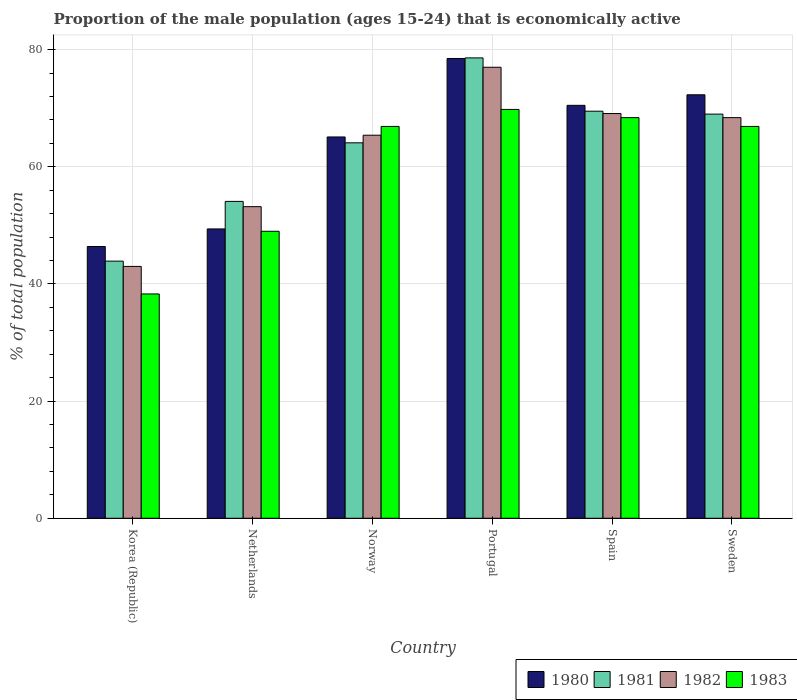How many different coloured bars are there?
Your response must be concise. 4. In how many cases, is the number of bars for a given country not equal to the number of legend labels?
Make the answer very short. 0. What is the proportion of the male population that is economically active in 1983 in Norway?
Your answer should be very brief. 66.9. Across all countries, what is the maximum proportion of the male population that is economically active in 1983?
Your response must be concise. 69.8. What is the total proportion of the male population that is economically active in 1980 in the graph?
Make the answer very short. 382.2. What is the difference between the proportion of the male population that is economically active in 1981 in Netherlands and that in Sweden?
Offer a terse response. -14.9. What is the difference between the proportion of the male population that is economically active in 1981 in Norway and the proportion of the male population that is economically active in 1980 in Portugal?
Offer a terse response. -14.4. What is the average proportion of the male population that is economically active in 1983 per country?
Provide a succinct answer. 59.88. What is the difference between the proportion of the male population that is economically active of/in 1981 and proportion of the male population that is economically active of/in 1983 in Portugal?
Your answer should be compact. 8.8. In how many countries, is the proportion of the male population that is economically active in 1982 greater than 4 %?
Your answer should be compact. 6. What is the ratio of the proportion of the male population that is economically active in 1982 in Korea (Republic) to that in Spain?
Make the answer very short. 0.62. What is the difference between the highest and the second highest proportion of the male population that is economically active in 1982?
Give a very brief answer. -7.9. What does the 1st bar from the right in Sweden represents?
Offer a terse response. 1983. Is it the case that in every country, the sum of the proportion of the male population that is economically active in 1983 and proportion of the male population that is economically active in 1982 is greater than the proportion of the male population that is economically active in 1981?
Your response must be concise. Yes. Are all the bars in the graph horizontal?
Offer a very short reply. No. What is the difference between two consecutive major ticks on the Y-axis?
Provide a short and direct response. 20. Are the values on the major ticks of Y-axis written in scientific E-notation?
Your response must be concise. No. Does the graph contain any zero values?
Offer a terse response. No. Does the graph contain grids?
Keep it short and to the point. Yes. Where does the legend appear in the graph?
Make the answer very short. Bottom right. How many legend labels are there?
Your answer should be very brief. 4. What is the title of the graph?
Your answer should be very brief. Proportion of the male population (ages 15-24) that is economically active. Does "2010" appear as one of the legend labels in the graph?
Provide a succinct answer. No. What is the label or title of the Y-axis?
Ensure brevity in your answer.  % of total population. What is the % of total population of 1980 in Korea (Republic)?
Offer a very short reply. 46.4. What is the % of total population in 1981 in Korea (Republic)?
Your response must be concise. 43.9. What is the % of total population of 1982 in Korea (Republic)?
Give a very brief answer. 43. What is the % of total population in 1983 in Korea (Republic)?
Keep it short and to the point. 38.3. What is the % of total population in 1980 in Netherlands?
Offer a terse response. 49.4. What is the % of total population in 1981 in Netherlands?
Provide a succinct answer. 54.1. What is the % of total population of 1982 in Netherlands?
Give a very brief answer. 53.2. What is the % of total population in 1980 in Norway?
Offer a very short reply. 65.1. What is the % of total population of 1981 in Norway?
Provide a short and direct response. 64.1. What is the % of total population of 1982 in Norway?
Provide a succinct answer. 65.4. What is the % of total population of 1983 in Norway?
Provide a succinct answer. 66.9. What is the % of total population in 1980 in Portugal?
Your answer should be very brief. 78.5. What is the % of total population of 1981 in Portugal?
Give a very brief answer. 78.6. What is the % of total population of 1982 in Portugal?
Make the answer very short. 77. What is the % of total population in 1983 in Portugal?
Your answer should be very brief. 69.8. What is the % of total population in 1980 in Spain?
Provide a short and direct response. 70.5. What is the % of total population of 1981 in Spain?
Give a very brief answer. 69.5. What is the % of total population in 1982 in Spain?
Ensure brevity in your answer.  69.1. What is the % of total population in 1983 in Spain?
Your response must be concise. 68.4. What is the % of total population in 1980 in Sweden?
Your answer should be very brief. 72.3. What is the % of total population of 1981 in Sweden?
Provide a succinct answer. 69. What is the % of total population in 1982 in Sweden?
Give a very brief answer. 68.4. What is the % of total population of 1983 in Sweden?
Ensure brevity in your answer.  66.9. Across all countries, what is the maximum % of total population of 1980?
Keep it short and to the point. 78.5. Across all countries, what is the maximum % of total population of 1981?
Your answer should be very brief. 78.6. Across all countries, what is the maximum % of total population in 1982?
Offer a very short reply. 77. Across all countries, what is the maximum % of total population of 1983?
Offer a very short reply. 69.8. Across all countries, what is the minimum % of total population of 1980?
Keep it short and to the point. 46.4. Across all countries, what is the minimum % of total population of 1981?
Offer a very short reply. 43.9. Across all countries, what is the minimum % of total population in 1982?
Give a very brief answer. 43. Across all countries, what is the minimum % of total population of 1983?
Your answer should be very brief. 38.3. What is the total % of total population of 1980 in the graph?
Make the answer very short. 382.2. What is the total % of total population in 1981 in the graph?
Ensure brevity in your answer.  379.2. What is the total % of total population in 1982 in the graph?
Give a very brief answer. 376.1. What is the total % of total population in 1983 in the graph?
Your answer should be very brief. 359.3. What is the difference between the % of total population of 1981 in Korea (Republic) and that in Netherlands?
Offer a very short reply. -10.2. What is the difference between the % of total population in 1983 in Korea (Republic) and that in Netherlands?
Provide a short and direct response. -10.7. What is the difference between the % of total population of 1980 in Korea (Republic) and that in Norway?
Offer a very short reply. -18.7. What is the difference between the % of total population of 1981 in Korea (Republic) and that in Norway?
Give a very brief answer. -20.2. What is the difference between the % of total population in 1982 in Korea (Republic) and that in Norway?
Give a very brief answer. -22.4. What is the difference between the % of total population in 1983 in Korea (Republic) and that in Norway?
Offer a very short reply. -28.6. What is the difference between the % of total population in 1980 in Korea (Republic) and that in Portugal?
Your answer should be compact. -32.1. What is the difference between the % of total population of 1981 in Korea (Republic) and that in Portugal?
Your answer should be very brief. -34.7. What is the difference between the % of total population in 1982 in Korea (Republic) and that in Portugal?
Offer a terse response. -34. What is the difference between the % of total population in 1983 in Korea (Republic) and that in Portugal?
Provide a succinct answer. -31.5. What is the difference between the % of total population of 1980 in Korea (Republic) and that in Spain?
Ensure brevity in your answer.  -24.1. What is the difference between the % of total population in 1981 in Korea (Republic) and that in Spain?
Provide a short and direct response. -25.6. What is the difference between the % of total population of 1982 in Korea (Republic) and that in Spain?
Provide a short and direct response. -26.1. What is the difference between the % of total population in 1983 in Korea (Republic) and that in Spain?
Provide a succinct answer. -30.1. What is the difference between the % of total population of 1980 in Korea (Republic) and that in Sweden?
Your answer should be compact. -25.9. What is the difference between the % of total population in 1981 in Korea (Republic) and that in Sweden?
Your answer should be very brief. -25.1. What is the difference between the % of total population in 1982 in Korea (Republic) and that in Sweden?
Make the answer very short. -25.4. What is the difference between the % of total population in 1983 in Korea (Republic) and that in Sweden?
Give a very brief answer. -28.6. What is the difference between the % of total population in 1980 in Netherlands and that in Norway?
Make the answer very short. -15.7. What is the difference between the % of total population in 1982 in Netherlands and that in Norway?
Your answer should be very brief. -12.2. What is the difference between the % of total population of 1983 in Netherlands and that in Norway?
Your response must be concise. -17.9. What is the difference between the % of total population in 1980 in Netherlands and that in Portugal?
Provide a short and direct response. -29.1. What is the difference between the % of total population in 1981 in Netherlands and that in Portugal?
Ensure brevity in your answer.  -24.5. What is the difference between the % of total population in 1982 in Netherlands and that in Portugal?
Provide a succinct answer. -23.8. What is the difference between the % of total population in 1983 in Netherlands and that in Portugal?
Keep it short and to the point. -20.8. What is the difference between the % of total population in 1980 in Netherlands and that in Spain?
Make the answer very short. -21.1. What is the difference between the % of total population of 1981 in Netherlands and that in Spain?
Your answer should be compact. -15.4. What is the difference between the % of total population in 1982 in Netherlands and that in Spain?
Keep it short and to the point. -15.9. What is the difference between the % of total population of 1983 in Netherlands and that in Spain?
Make the answer very short. -19.4. What is the difference between the % of total population in 1980 in Netherlands and that in Sweden?
Provide a succinct answer. -22.9. What is the difference between the % of total population of 1981 in Netherlands and that in Sweden?
Your answer should be very brief. -14.9. What is the difference between the % of total population in 1982 in Netherlands and that in Sweden?
Make the answer very short. -15.2. What is the difference between the % of total population of 1983 in Netherlands and that in Sweden?
Your response must be concise. -17.9. What is the difference between the % of total population of 1981 in Norway and that in Portugal?
Your response must be concise. -14.5. What is the difference between the % of total population of 1980 in Norway and that in Spain?
Provide a short and direct response. -5.4. What is the difference between the % of total population of 1982 in Norway and that in Spain?
Your response must be concise. -3.7. What is the difference between the % of total population in 1983 in Norway and that in Spain?
Provide a short and direct response. -1.5. What is the difference between the % of total population of 1980 in Norway and that in Sweden?
Offer a terse response. -7.2. What is the difference between the % of total population of 1982 in Norway and that in Sweden?
Your answer should be compact. -3. What is the difference between the % of total population of 1980 in Portugal and that in Spain?
Give a very brief answer. 8. What is the difference between the % of total population of 1983 in Portugal and that in Sweden?
Give a very brief answer. 2.9. What is the difference between the % of total population of 1980 in Spain and that in Sweden?
Ensure brevity in your answer.  -1.8. What is the difference between the % of total population in 1981 in Spain and that in Sweden?
Offer a terse response. 0.5. What is the difference between the % of total population of 1983 in Spain and that in Sweden?
Provide a short and direct response. 1.5. What is the difference between the % of total population in 1980 in Korea (Republic) and the % of total population in 1981 in Netherlands?
Give a very brief answer. -7.7. What is the difference between the % of total population of 1982 in Korea (Republic) and the % of total population of 1983 in Netherlands?
Provide a short and direct response. -6. What is the difference between the % of total population in 1980 in Korea (Republic) and the % of total population in 1981 in Norway?
Offer a very short reply. -17.7. What is the difference between the % of total population of 1980 in Korea (Republic) and the % of total population of 1983 in Norway?
Your answer should be very brief. -20.5. What is the difference between the % of total population of 1981 in Korea (Republic) and the % of total population of 1982 in Norway?
Your answer should be very brief. -21.5. What is the difference between the % of total population of 1982 in Korea (Republic) and the % of total population of 1983 in Norway?
Offer a very short reply. -23.9. What is the difference between the % of total population of 1980 in Korea (Republic) and the % of total population of 1981 in Portugal?
Keep it short and to the point. -32.2. What is the difference between the % of total population of 1980 in Korea (Republic) and the % of total population of 1982 in Portugal?
Your answer should be very brief. -30.6. What is the difference between the % of total population of 1980 in Korea (Republic) and the % of total population of 1983 in Portugal?
Provide a short and direct response. -23.4. What is the difference between the % of total population in 1981 in Korea (Republic) and the % of total population in 1982 in Portugal?
Provide a short and direct response. -33.1. What is the difference between the % of total population of 1981 in Korea (Republic) and the % of total population of 1983 in Portugal?
Make the answer very short. -25.9. What is the difference between the % of total population in 1982 in Korea (Republic) and the % of total population in 1983 in Portugal?
Provide a short and direct response. -26.8. What is the difference between the % of total population in 1980 in Korea (Republic) and the % of total population in 1981 in Spain?
Offer a very short reply. -23.1. What is the difference between the % of total population of 1980 in Korea (Republic) and the % of total population of 1982 in Spain?
Offer a very short reply. -22.7. What is the difference between the % of total population in 1980 in Korea (Republic) and the % of total population in 1983 in Spain?
Ensure brevity in your answer.  -22. What is the difference between the % of total population of 1981 in Korea (Republic) and the % of total population of 1982 in Spain?
Your response must be concise. -25.2. What is the difference between the % of total population in 1981 in Korea (Republic) and the % of total population in 1983 in Spain?
Give a very brief answer. -24.5. What is the difference between the % of total population in 1982 in Korea (Republic) and the % of total population in 1983 in Spain?
Offer a very short reply. -25.4. What is the difference between the % of total population of 1980 in Korea (Republic) and the % of total population of 1981 in Sweden?
Keep it short and to the point. -22.6. What is the difference between the % of total population of 1980 in Korea (Republic) and the % of total population of 1982 in Sweden?
Your response must be concise. -22. What is the difference between the % of total population in 1980 in Korea (Republic) and the % of total population in 1983 in Sweden?
Provide a succinct answer. -20.5. What is the difference between the % of total population in 1981 in Korea (Republic) and the % of total population in 1982 in Sweden?
Make the answer very short. -24.5. What is the difference between the % of total population in 1981 in Korea (Republic) and the % of total population in 1983 in Sweden?
Offer a terse response. -23. What is the difference between the % of total population in 1982 in Korea (Republic) and the % of total population in 1983 in Sweden?
Your answer should be compact. -23.9. What is the difference between the % of total population of 1980 in Netherlands and the % of total population of 1981 in Norway?
Your answer should be compact. -14.7. What is the difference between the % of total population in 1980 in Netherlands and the % of total population in 1983 in Norway?
Your response must be concise. -17.5. What is the difference between the % of total population of 1981 in Netherlands and the % of total population of 1982 in Norway?
Offer a very short reply. -11.3. What is the difference between the % of total population in 1981 in Netherlands and the % of total population in 1983 in Norway?
Your answer should be compact. -12.8. What is the difference between the % of total population of 1982 in Netherlands and the % of total population of 1983 in Norway?
Ensure brevity in your answer.  -13.7. What is the difference between the % of total population of 1980 in Netherlands and the % of total population of 1981 in Portugal?
Make the answer very short. -29.2. What is the difference between the % of total population of 1980 in Netherlands and the % of total population of 1982 in Portugal?
Ensure brevity in your answer.  -27.6. What is the difference between the % of total population of 1980 in Netherlands and the % of total population of 1983 in Portugal?
Your answer should be compact. -20.4. What is the difference between the % of total population of 1981 in Netherlands and the % of total population of 1982 in Portugal?
Your response must be concise. -22.9. What is the difference between the % of total population of 1981 in Netherlands and the % of total population of 1983 in Portugal?
Keep it short and to the point. -15.7. What is the difference between the % of total population of 1982 in Netherlands and the % of total population of 1983 in Portugal?
Provide a succinct answer. -16.6. What is the difference between the % of total population in 1980 in Netherlands and the % of total population in 1981 in Spain?
Your response must be concise. -20.1. What is the difference between the % of total population of 1980 in Netherlands and the % of total population of 1982 in Spain?
Make the answer very short. -19.7. What is the difference between the % of total population in 1981 in Netherlands and the % of total population in 1983 in Spain?
Give a very brief answer. -14.3. What is the difference between the % of total population in 1982 in Netherlands and the % of total population in 1983 in Spain?
Provide a succinct answer. -15.2. What is the difference between the % of total population of 1980 in Netherlands and the % of total population of 1981 in Sweden?
Ensure brevity in your answer.  -19.6. What is the difference between the % of total population of 1980 in Netherlands and the % of total population of 1983 in Sweden?
Make the answer very short. -17.5. What is the difference between the % of total population in 1981 in Netherlands and the % of total population in 1982 in Sweden?
Your answer should be compact. -14.3. What is the difference between the % of total population in 1982 in Netherlands and the % of total population in 1983 in Sweden?
Give a very brief answer. -13.7. What is the difference between the % of total population in 1980 in Norway and the % of total population in 1981 in Portugal?
Offer a terse response. -13.5. What is the difference between the % of total population in 1980 in Norway and the % of total population in 1982 in Portugal?
Give a very brief answer. -11.9. What is the difference between the % of total population of 1980 in Norway and the % of total population of 1983 in Portugal?
Provide a succinct answer. -4.7. What is the difference between the % of total population of 1981 in Norway and the % of total population of 1982 in Portugal?
Your response must be concise. -12.9. What is the difference between the % of total population of 1980 in Norway and the % of total population of 1981 in Sweden?
Offer a very short reply. -3.9. What is the difference between the % of total population of 1980 in Norway and the % of total population of 1983 in Sweden?
Make the answer very short. -1.8. What is the difference between the % of total population of 1981 in Norway and the % of total population of 1982 in Sweden?
Make the answer very short. -4.3. What is the difference between the % of total population in 1981 in Norway and the % of total population in 1983 in Sweden?
Offer a terse response. -2.8. What is the difference between the % of total population in 1982 in Norway and the % of total population in 1983 in Sweden?
Your answer should be compact. -1.5. What is the difference between the % of total population in 1980 in Portugal and the % of total population in 1983 in Spain?
Ensure brevity in your answer.  10.1. What is the difference between the % of total population of 1982 in Portugal and the % of total population of 1983 in Spain?
Provide a succinct answer. 8.6. What is the difference between the % of total population in 1982 in Portugal and the % of total population in 1983 in Sweden?
Your answer should be compact. 10.1. What is the difference between the % of total population in 1980 in Spain and the % of total population in 1983 in Sweden?
Keep it short and to the point. 3.6. What is the difference between the % of total population in 1981 in Spain and the % of total population in 1982 in Sweden?
Provide a short and direct response. 1.1. What is the average % of total population in 1980 per country?
Keep it short and to the point. 63.7. What is the average % of total population of 1981 per country?
Your answer should be compact. 63.2. What is the average % of total population of 1982 per country?
Provide a succinct answer. 62.68. What is the average % of total population of 1983 per country?
Provide a succinct answer. 59.88. What is the difference between the % of total population in 1981 and % of total population in 1982 in Korea (Republic)?
Offer a terse response. 0.9. What is the difference between the % of total population of 1981 and % of total population of 1983 in Netherlands?
Your answer should be compact. 5.1. What is the difference between the % of total population in 1982 and % of total population in 1983 in Netherlands?
Keep it short and to the point. 4.2. What is the difference between the % of total population in 1980 and % of total population in 1981 in Norway?
Offer a terse response. 1. What is the difference between the % of total population in 1980 and % of total population in 1982 in Norway?
Keep it short and to the point. -0.3. What is the difference between the % of total population in 1980 and % of total population in 1983 in Norway?
Give a very brief answer. -1.8. What is the difference between the % of total population of 1982 and % of total population of 1983 in Norway?
Give a very brief answer. -1.5. What is the difference between the % of total population in 1981 and % of total population in 1982 in Portugal?
Provide a short and direct response. 1.6. What is the difference between the % of total population of 1980 and % of total population of 1981 in Spain?
Offer a very short reply. 1. What is the difference between the % of total population of 1980 and % of total population of 1982 in Spain?
Offer a very short reply. 1.4. What is the difference between the % of total population in 1980 and % of total population in 1983 in Spain?
Your answer should be very brief. 2.1. What is the difference between the % of total population in 1981 and % of total population in 1983 in Spain?
Your answer should be compact. 1.1. What is the difference between the % of total population of 1982 and % of total population of 1983 in Spain?
Your answer should be very brief. 0.7. What is the difference between the % of total population in 1980 and % of total population in 1982 in Sweden?
Your answer should be compact. 3.9. What is the difference between the % of total population of 1981 and % of total population of 1982 in Sweden?
Your response must be concise. 0.6. What is the difference between the % of total population in 1981 and % of total population in 1983 in Sweden?
Your answer should be compact. 2.1. What is the difference between the % of total population in 1982 and % of total population in 1983 in Sweden?
Your response must be concise. 1.5. What is the ratio of the % of total population of 1980 in Korea (Republic) to that in Netherlands?
Keep it short and to the point. 0.94. What is the ratio of the % of total population of 1981 in Korea (Republic) to that in Netherlands?
Your response must be concise. 0.81. What is the ratio of the % of total population in 1982 in Korea (Republic) to that in Netherlands?
Provide a succinct answer. 0.81. What is the ratio of the % of total population of 1983 in Korea (Republic) to that in Netherlands?
Your answer should be very brief. 0.78. What is the ratio of the % of total population in 1980 in Korea (Republic) to that in Norway?
Provide a succinct answer. 0.71. What is the ratio of the % of total population in 1981 in Korea (Republic) to that in Norway?
Your answer should be very brief. 0.68. What is the ratio of the % of total population in 1982 in Korea (Republic) to that in Norway?
Your answer should be compact. 0.66. What is the ratio of the % of total population of 1983 in Korea (Republic) to that in Norway?
Your answer should be compact. 0.57. What is the ratio of the % of total population of 1980 in Korea (Republic) to that in Portugal?
Your response must be concise. 0.59. What is the ratio of the % of total population of 1981 in Korea (Republic) to that in Portugal?
Provide a short and direct response. 0.56. What is the ratio of the % of total population of 1982 in Korea (Republic) to that in Portugal?
Give a very brief answer. 0.56. What is the ratio of the % of total population in 1983 in Korea (Republic) to that in Portugal?
Ensure brevity in your answer.  0.55. What is the ratio of the % of total population of 1980 in Korea (Republic) to that in Spain?
Provide a short and direct response. 0.66. What is the ratio of the % of total population in 1981 in Korea (Republic) to that in Spain?
Your answer should be very brief. 0.63. What is the ratio of the % of total population in 1982 in Korea (Republic) to that in Spain?
Provide a short and direct response. 0.62. What is the ratio of the % of total population in 1983 in Korea (Republic) to that in Spain?
Give a very brief answer. 0.56. What is the ratio of the % of total population of 1980 in Korea (Republic) to that in Sweden?
Keep it short and to the point. 0.64. What is the ratio of the % of total population in 1981 in Korea (Republic) to that in Sweden?
Your answer should be very brief. 0.64. What is the ratio of the % of total population of 1982 in Korea (Republic) to that in Sweden?
Give a very brief answer. 0.63. What is the ratio of the % of total population of 1983 in Korea (Republic) to that in Sweden?
Your answer should be compact. 0.57. What is the ratio of the % of total population in 1980 in Netherlands to that in Norway?
Your response must be concise. 0.76. What is the ratio of the % of total population in 1981 in Netherlands to that in Norway?
Offer a very short reply. 0.84. What is the ratio of the % of total population of 1982 in Netherlands to that in Norway?
Your answer should be compact. 0.81. What is the ratio of the % of total population of 1983 in Netherlands to that in Norway?
Keep it short and to the point. 0.73. What is the ratio of the % of total population in 1980 in Netherlands to that in Portugal?
Offer a terse response. 0.63. What is the ratio of the % of total population of 1981 in Netherlands to that in Portugal?
Provide a short and direct response. 0.69. What is the ratio of the % of total population in 1982 in Netherlands to that in Portugal?
Your response must be concise. 0.69. What is the ratio of the % of total population of 1983 in Netherlands to that in Portugal?
Offer a very short reply. 0.7. What is the ratio of the % of total population in 1980 in Netherlands to that in Spain?
Provide a succinct answer. 0.7. What is the ratio of the % of total population in 1981 in Netherlands to that in Spain?
Provide a succinct answer. 0.78. What is the ratio of the % of total population in 1982 in Netherlands to that in Spain?
Offer a very short reply. 0.77. What is the ratio of the % of total population in 1983 in Netherlands to that in Spain?
Offer a very short reply. 0.72. What is the ratio of the % of total population in 1980 in Netherlands to that in Sweden?
Keep it short and to the point. 0.68. What is the ratio of the % of total population in 1981 in Netherlands to that in Sweden?
Your answer should be compact. 0.78. What is the ratio of the % of total population in 1982 in Netherlands to that in Sweden?
Ensure brevity in your answer.  0.78. What is the ratio of the % of total population in 1983 in Netherlands to that in Sweden?
Provide a short and direct response. 0.73. What is the ratio of the % of total population in 1980 in Norway to that in Portugal?
Your answer should be compact. 0.83. What is the ratio of the % of total population of 1981 in Norway to that in Portugal?
Your answer should be very brief. 0.82. What is the ratio of the % of total population in 1982 in Norway to that in Portugal?
Your answer should be compact. 0.85. What is the ratio of the % of total population in 1983 in Norway to that in Portugal?
Provide a short and direct response. 0.96. What is the ratio of the % of total population in 1980 in Norway to that in Spain?
Provide a short and direct response. 0.92. What is the ratio of the % of total population of 1981 in Norway to that in Spain?
Offer a terse response. 0.92. What is the ratio of the % of total population of 1982 in Norway to that in Spain?
Make the answer very short. 0.95. What is the ratio of the % of total population of 1983 in Norway to that in Spain?
Offer a terse response. 0.98. What is the ratio of the % of total population in 1980 in Norway to that in Sweden?
Ensure brevity in your answer.  0.9. What is the ratio of the % of total population of 1981 in Norway to that in Sweden?
Keep it short and to the point. 0.93. What is the ratio of the % of total population of 1982 in Norway to that in Sweden?
Your answer should be compact. 0.96. What is the ratio of the % of total population of 1980 in Portugal to that in Spain?
Provide a short and direct response. 1.11. What is the ratio of the % of total population of 1981 in Portugal to that in Spain?
Give a very brief answer. 1.13. What is the ratio of the % of total population of 1982 in Portugal to that in Spain?
Offer a very short reply. 1.11. What is the ratio of the % of total population in 1983 in Portugal to that in Spain?
Your answer should be very brief. 1.02. What is the ratio of the % of total population in 1980 in Portugal to that in Sweden?
Make the answer very short. 1.09. What is the ratio of the % of total population of 1981 in Portugal to that in Sweden?
Make the answer very short. 1.14. What is the ratio of the % of total population of 1982 in Portugal to that in Sweden?
Keep it short and to the point. 1.13. What is the ratio of the % of total population of 1983 in Portugal to that in Sweden?
Keep it short and to the point. 1.04. What is the ratio of the % of total population in 1980 in Spain to that in Sweden?
Make the answer very short. 0.98. What is the ratio of the % of total population in 1981 in Spain to that in Sweden?
Ensure brevity in your answer.  1.01. What is the ratio of the % of total population of 1982 in Spain to that in Sweden?
Provide a succinct answer. 1.01. What is the ratio of the % of total population in 1983 in Spain to that in Sweden?
Your answer should be compact. 1.02. What is the difference between the highest and the second highest % of total population in 1982?
Make the answer very short. 7.9. What is the difference between the highest and the second highest % of total population in 1983?
Offer a terse response. 1.4. What is the difference between the highest and the lowest % of total population in 1980?
Give a very brief answer. 32.1. What is the difference between the highest and the lowest % of total population in 1981?
Your answer should be very brief. 34.7. What is the difference between the highest and the lowest % of total population of 1983?
Provide a succinct answer. 31.5. 